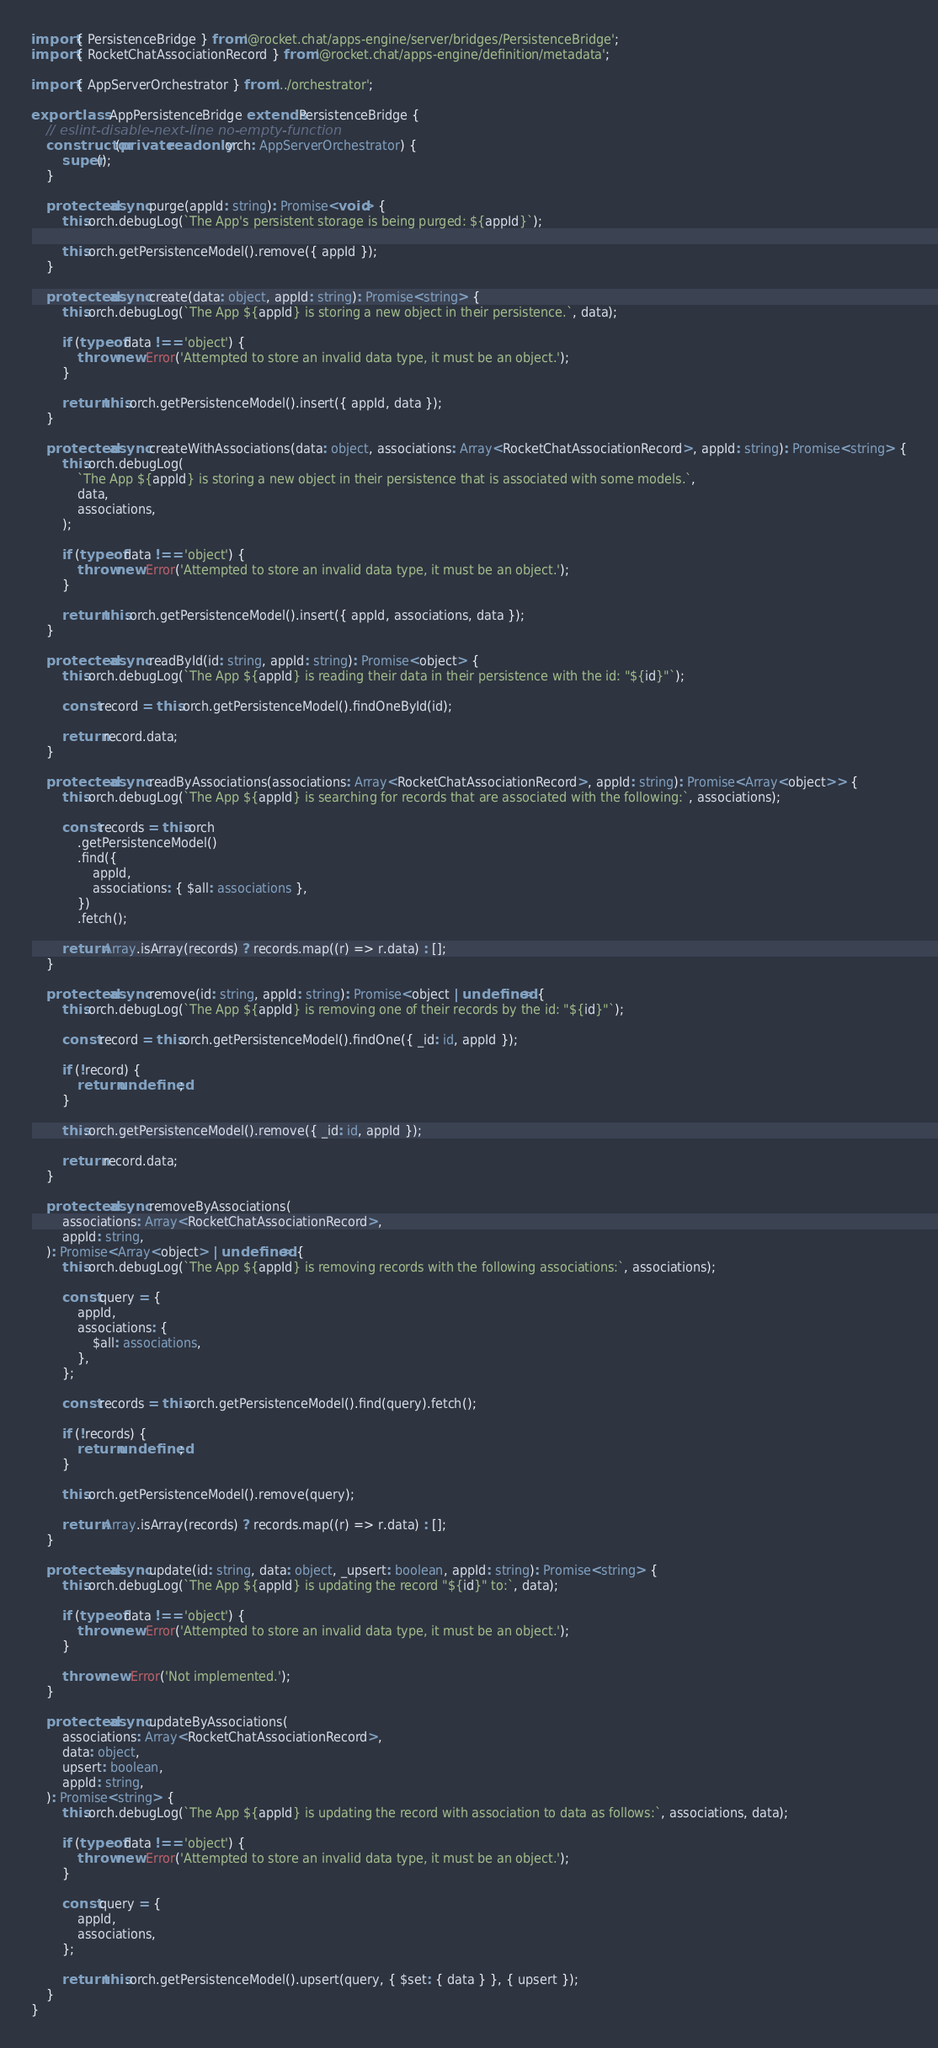Convert code to text. <code><loc_0><loc_0><loc_500><loc_500><_TypeScript_>import { PersistenceBridge } from '@rocket.chat/apps-engine/server/bridges/PersistenceBridge';
import { RocketChatAssociationRecord } from '@rocket.chat/apps-engine/definition/metadata';

import { AppServerOrchestrator } from '../orchestrator';

export class AppPersistenceBridge extends PersistenceBridge {
	// eslint-disable-next-line no-empty-function
	constructor(private readonly orch: AppServerOrchestrator) {
		super();
	}

	protected async purge(appId: string): Promise<void> {
		this.orch.debugLog(`The App's persistent storage is being purged: ${appId}`);

		this.orch.getPersistenceModel().remove({ appId });
	}

	protected async create(data: object, appId: string): Promise<string> {
		this.orch.debugLog(`The App ${appId} is storing a new object in their persistence.`, data);

		if (typeof data !== 'object') {
			throw new Error('Attempted to store an invalid data type, it must be an object.');
		}

		return this.orch.getPersistenceModel().insert({ appId, data });
	}

	protected async createWithAssociations(data: object, associations: Array<RocketChatAssociationRecord>, appId: string): Promise<string> {
		this.orch.debugLog(
			`The App ${appId} is storing a new object in their persistence that is associated with some models.`,
			data,
			associations,
		);

		if (typeof data !== 'object') {
			throw new Error('Attempted to store an invalid data type, it must be an object.');
		}

		return this.orch.getPersistenceModel().insert({ appId, associations, data });
	}

	protected async readById(id: string, appId: string): Promise<object> {
		this.orch.debugLog(`The App ${appId} is reading their data in their persistence with the id: "${id}"`);

		const record = this.orch.getPersistenceModel().findOneById(id);

		return record.data;
	}

	protected async readByAssociations(associations: Array<RocketChatAssociationRecord>, appId: string): Promise<Array<object>> {
		this.orch.debugLog(`The App ${appId} is searching for records that are associated with the following:`, associations);

		const records = this.orch
			.getPersistenceModel()
			.find({
				appId,
				associations: { $all: associations },
			})
			.fetch();

		return Array.isArray(records) ? records.map((r) => r.data) : [];
	}

	protected async remove(id: string, appId: string): Promise<object | undefined> {
		this.orch.debugLog(`The App ${appId} is removing one of their records by the id: "${id}"`);

		const record = this.orch.getPersistenceModel().findOne({ _id: id, appId });

		if (!record) {
			return undefined;
		}

		this.orch.getPersistenceModel().remove({ _id: id, appId });

		return record.data;
	}

	protected async removeByAssociations(
		associations: Array<RocketChatAssociationRecord>,
		appId: string,
	): Promise<Array<object> | undefined> {
		this.orch.debugLog(`The App ${appId} is removing records with the following associations:`, associations);

		const query = {
			appId,
			associations: {
				$all: associations,
			},
		};

		const records = this.orch.getPersistenceModel().find(query).fetch();

		if (!records) {
			return undefined;
		}

		this.orch.getPersistenceModel().remove(query);

		return Array.isArray(records) ? records.map((r) => r.data) : [];
	}

	protected async update(id: string, data: object, _upsert: boolean, appId: string): Promise<string> {
		this.orch.debugLog(`The App ${appId} is updating the record "${id}" to:`, data);

		if (typeof data !== 'object') {
			throw new Error('Attempted to store an invalid data type, it must be an object.');
		}

		throw new Error('Not implemented.');
	}

	protected async updateByAssociations(
		associations: Array<RocketChatAssociationRecord>,
		data: object,
		upsert: boolean,
		appId: string,
	): Promise<string> {
		this.orch.debugLog(`The App ${appId} is updating the record with association to data as follows:`, associations, data);

		if (typeof data !== 'object') {
			throw new Error('Attempted to store an invalid data type, it must be an object.');
		}

		const query = {
			appId,
			associations,
		};

		return this.orch.getPersistenceModel().upsert(query, { $set: { data } }, { upsert });
	}
}
</code> 